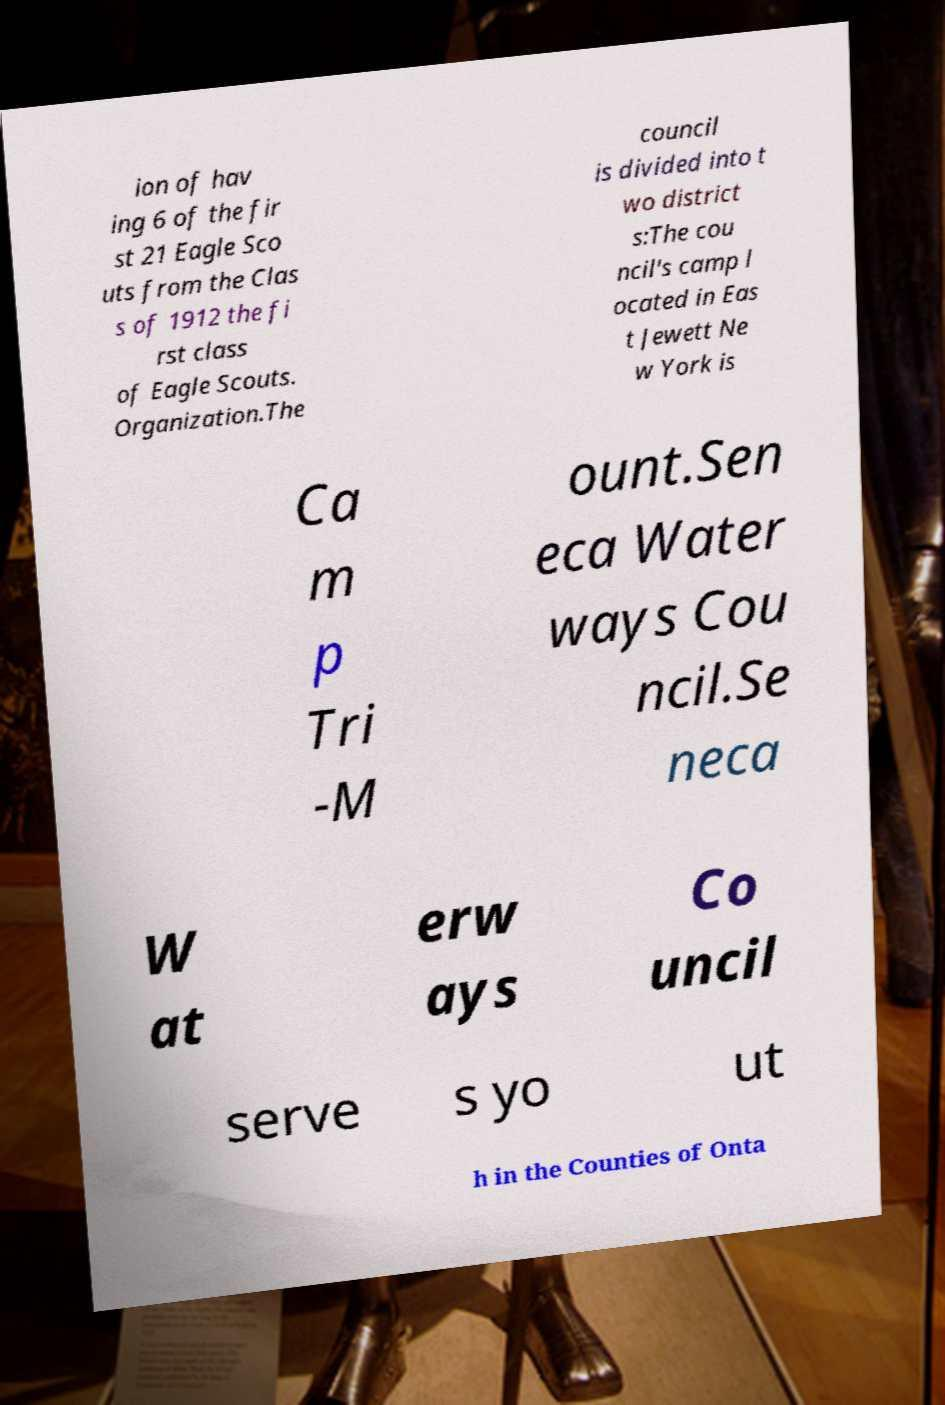For documentation purposes, I need the text within this image transcribed. Could you provide that? ion of hav ing 6 of the fir st 21 Eagle Sco uts from the Clas s of 1912 the fi rst class of Eagle Scouts. Organization.The council is divided into t wo district s:The cou ncil's camp l ocated in Eas t Jewett Ne w York is Ca m p Tri -M ount.Sen eca Water ways Cou ncil.Se neca W at erw ays Co uncil serve s yo ut h in the Counties of Onta 